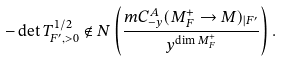Convert formula to latex. <formula><loc_0><loc_0><loc_500><loc_500>- \det T ^ { 1 / 2 } _ { F ^ { \prime } , > 0 } \notin N \left ( \frac { m C _ { - y } ^ { A } ( M ^ { + } _ { F } \to M ) _ { | F ^ { \prime } } } { y ^ { \dim M _ { F } ^ { + } } } \right ) .</formula> 